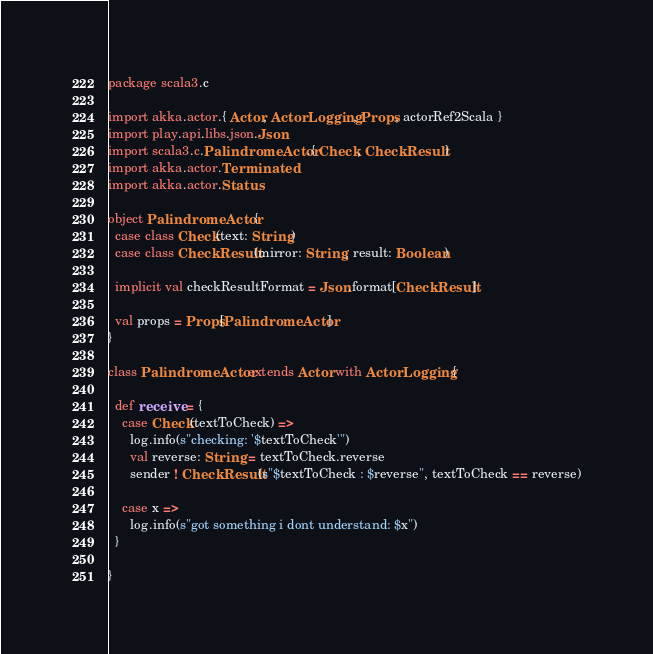<code> <loc_0><loc_0><loc_500><loc_500><_Scala_>package scala3.c

import akka.actor.{ Actor, ActorLogging, Props, actorRef2Scala }
import play.api.libs.json.Json
import scala3.c.PalindromeActor.{ Check, CheckResult }
import akka.actor.Terminated
import akka.actor.Status

object PalindromeActor {
  case class Check(text: String)
  case class CheckResult(mirror: String, result: Boolean)
  
  implicit val checkResultFormat = Json.format[CheckResult]
  
  val props = Props[PalindromeActor]
}

class PalindromeActor extends Actor with ActorLogging {
  
  def receive = {
    case Check(textToCheck) =>
      log.info(s"checking: '$textToCheck'")
      val reverse: String = textToCheck.reverse
      sender ! CheckResult(s"$textToCheck : $reverse", textToCheck == reverse)
    
    case x =>
      log.info(s"got something i dont understand: $x")
  }
  
}
</code> 